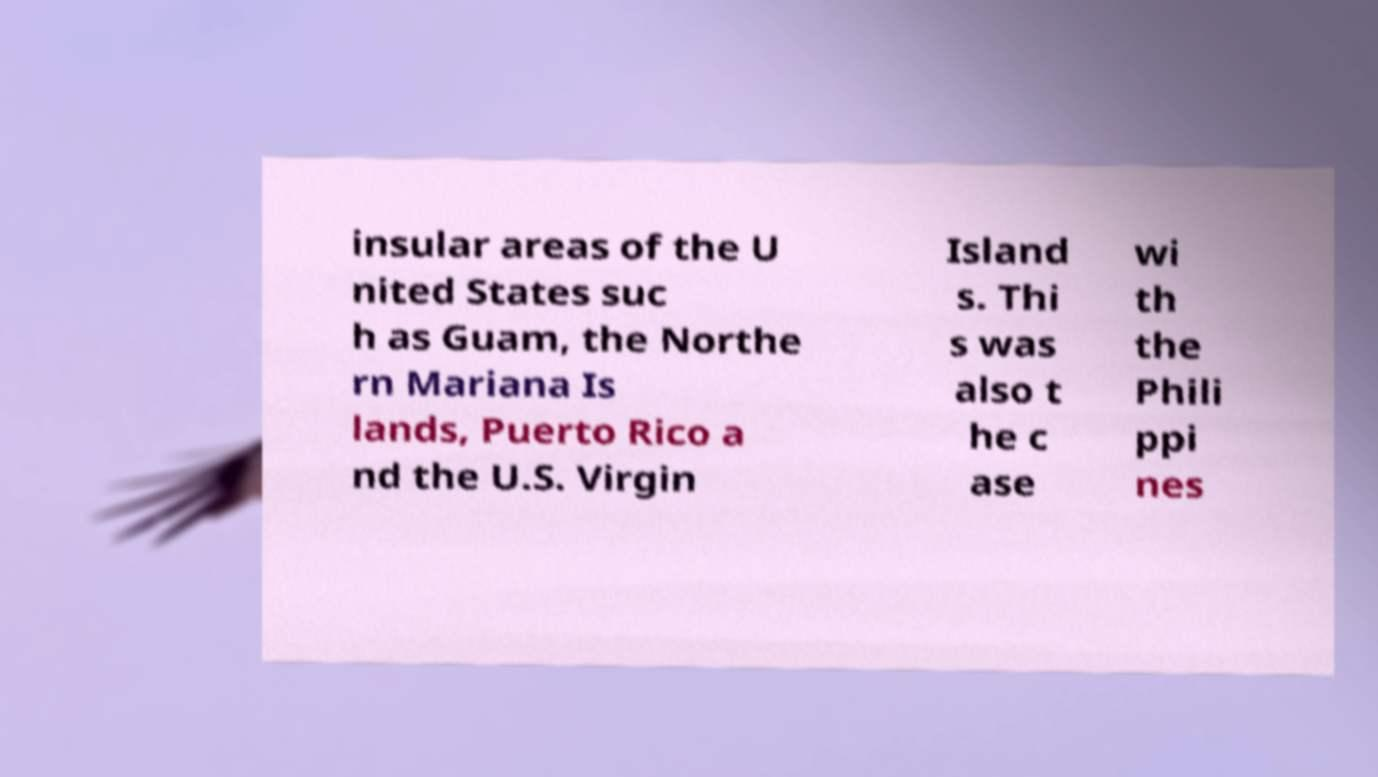Can you read and provide the text displayed in the image?This photo seems to have some interesting text. Can you extract and type it out for me? insular areas of the U nited States suc h as Guam, the Northe rn Mariana Is lands, Puerto Rico a nd the U.S. Virgin Island s. Thi s was also t he c ase wi th the Phili ppi nes 